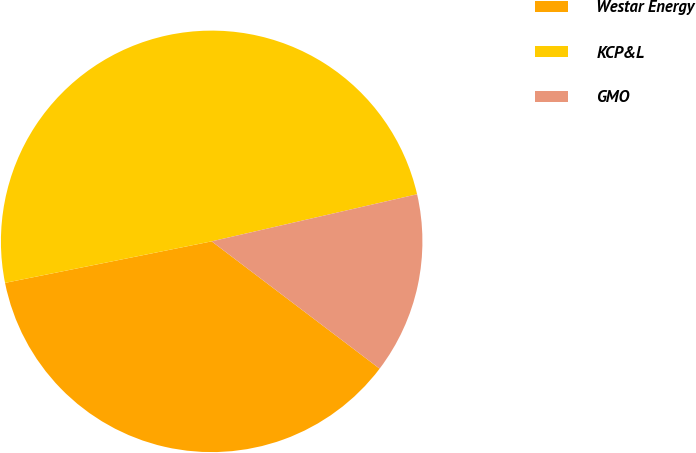Convert chart. <chart><loc_0><loc_0><loc_500><loc_500><pie_chart><fcel>Westar Energy<fcel>KCP&L<fcel>GMO<nl><fcel>36.52%<fcel>49.57%<fcel>13.91%<nl></chart> 